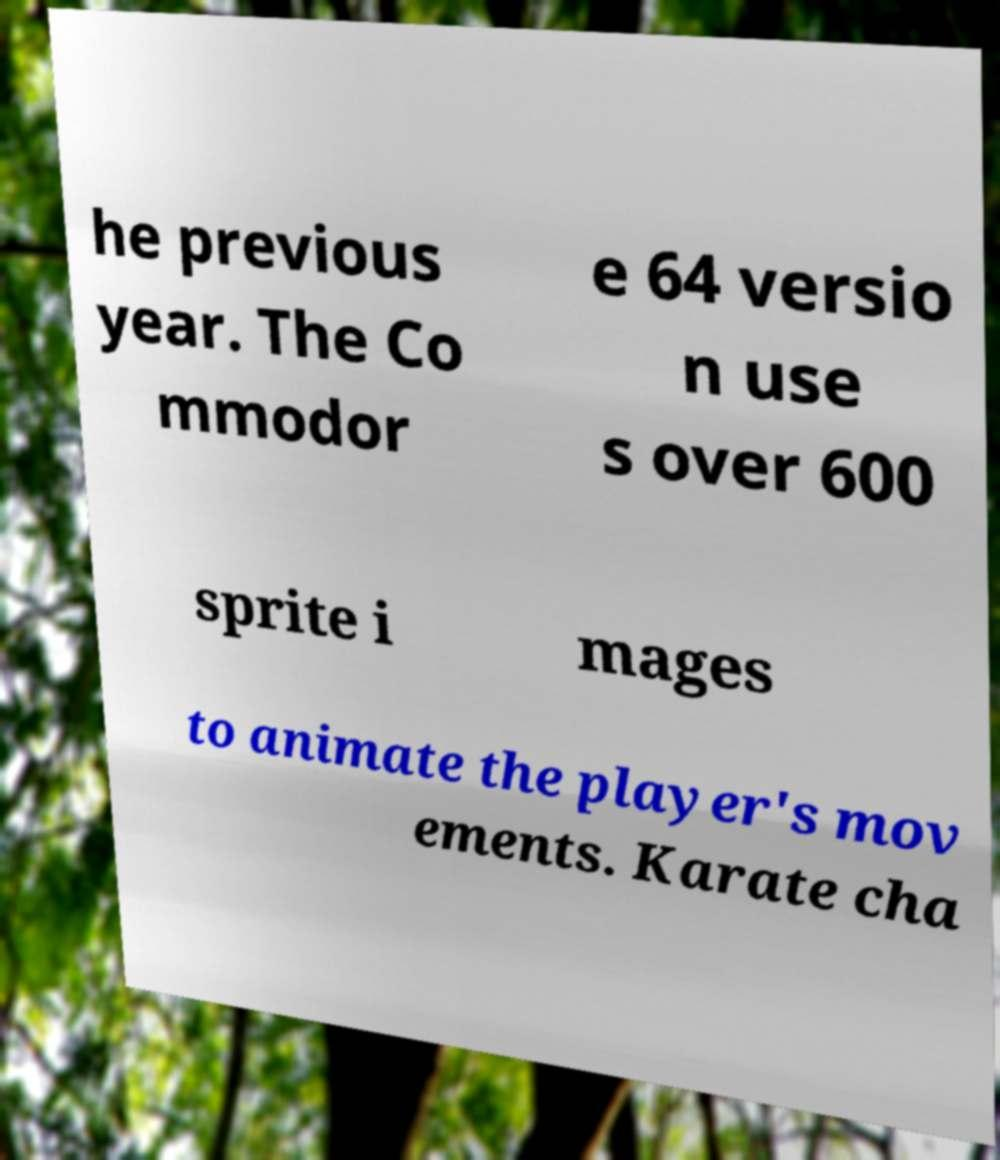Could you assist in decoding the text presented in this image and type it out clearly? he previous year. The Co mmodor e 64 versio n use s over 600 sprite i mages to animate the player's mov ements. Karate cha 